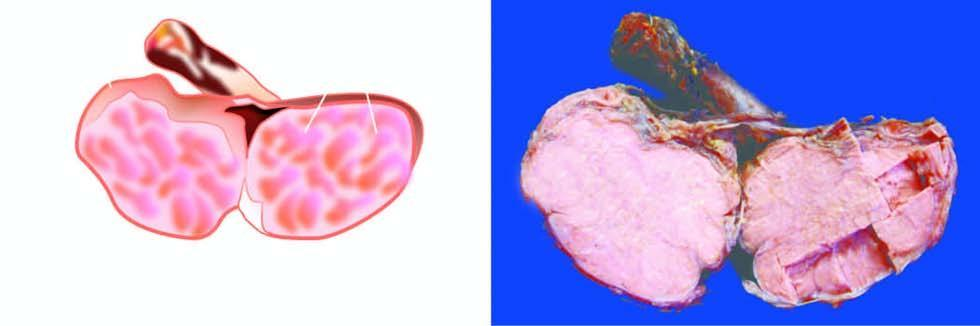how does sectioned surface show replacement of the entire testis?
Answer the question using a single word or phrase. By lobulated 